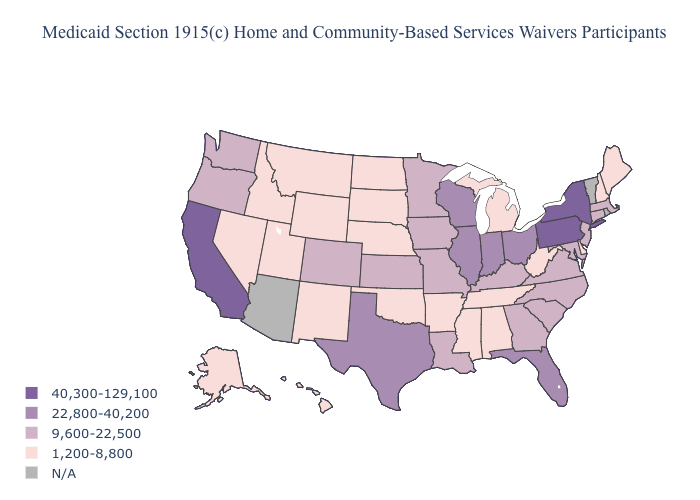Does Arkansas have the lowest value in the South?
Give a very brief answer. Yes. Which states have the highest value in the USA?
Keep it brief. California, New York, Pennsylvania. What is the lowest value in states that border Kansas?
Be succinct. 1,200-8,800. Is the legend a continuous bar?
Keep it brief. No. What is the highest value in states that border Arkansas?
Short answer required. 22,800-40,200. What is the value of Oklahoma?
Keep it brief. 1,200-8,800. What is the lowest value in the USA?
Write a very short answer. 1,200-8,800. Name the states that have a value in the range 22,800-40,200?
Be succinct. Florida, Illinois, Indiana, Ohio, Texas, Wisconsin. What is the value of Michigan?
Keep it brief. 1,200-8,800. Name the states that have a value in the range 1,200-8,800?
Short answer required. Alabama, Alaska, Arkansas, Delaware, Hawaii, Idaho, Maine, Michigan, Mississippi, Montana, Nebraska, Nevada, New Hampshire, New Mexico, North Dakota, Oklahoma, South Dakota, Tennessee, Utah, West Virginia, Wyoming. Which states have the highest value in the USA?
Quick response, please. California, New York, Pennsylvania. Is the legend a continuous bar?
Short answer required. No. What is the highest value in states that border Rhode Island?
Answer briefly. 9,600-22,500. 